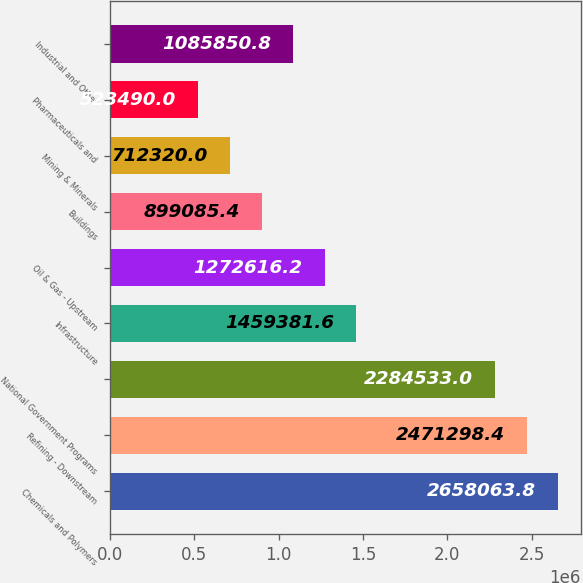Convert chart. <chart><loc_0><loc_0><loc_500><loc_500><bar_chart><fcel>Chemicals and Polymers<fcel>Refining - Downstream<fcel>National Government Programs<fcel>Infrastructure<fcel>Oil & Gas - Upstream<fcel>Buildings<fcel>Mining & Minerals<fcel>Pharmaceuticals and<fcel>Industrial and Other<nl><fcel>2.65806e+06<fcel>2.4713e+06<fcel>2.28453e+06<fcel>1.45938e+06<fcel>1.27262e+06<fcel>899085<fcel>712320<fcel>523490<fcel>1.08585e+06<nl></chart> 